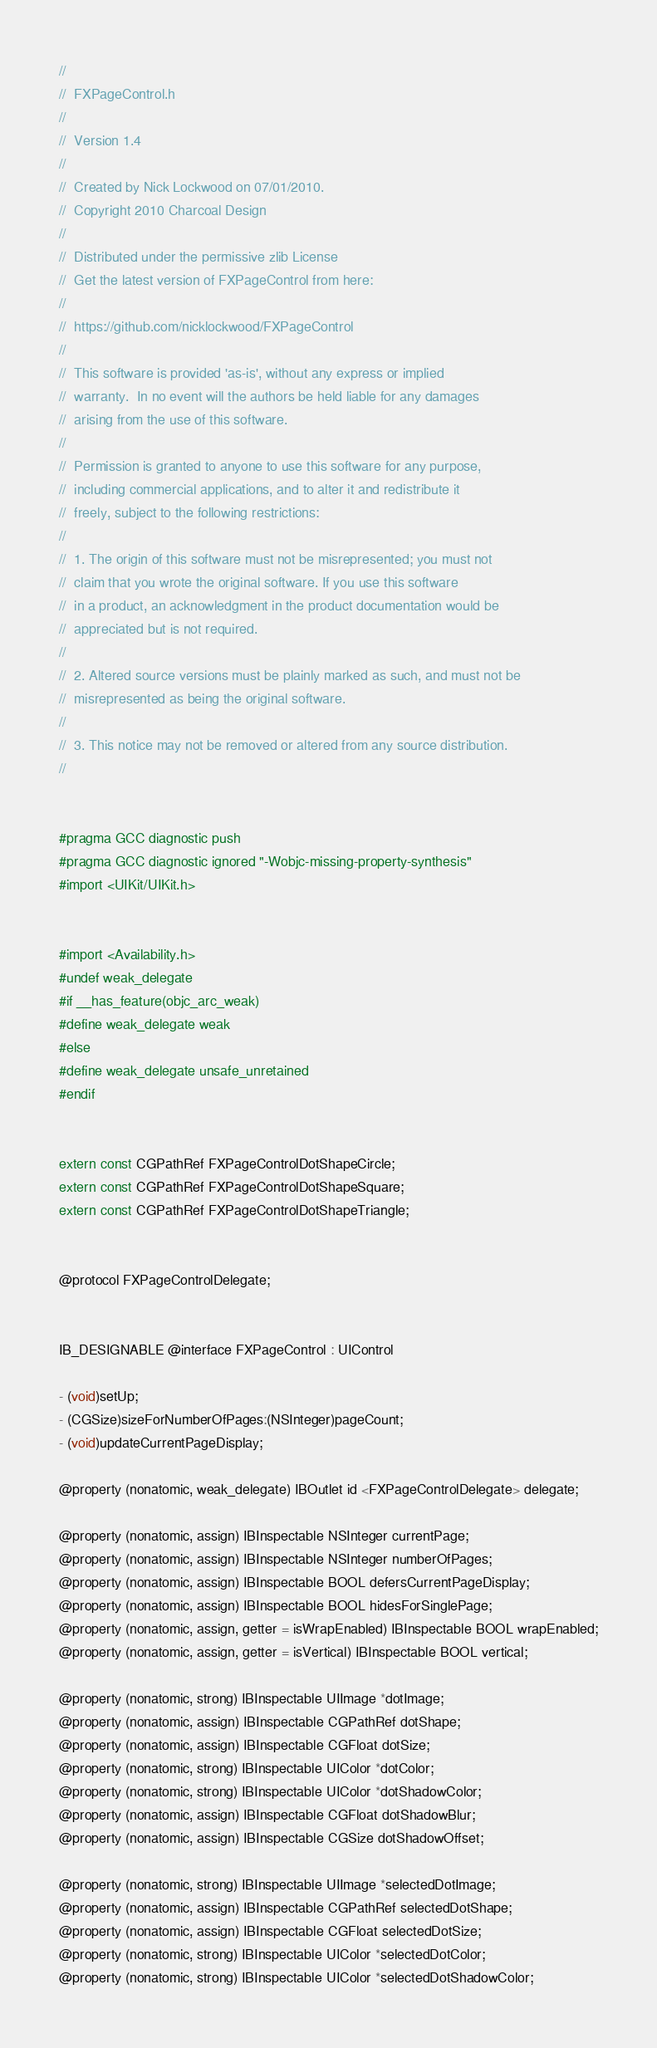<code> <loc_0><loc_0><loc_500><loc_500><_C_>//
//  FXPageControl.h
//
//  Version 1.4
//
//  Created by Nick Lockwood on 07/01/2010.
//  Copyright 2010 Charcoal Design
//
//  Distributed under the permissive zlib License
//  Get the latest version of FXPageControl from here:
//
//  https://github.com/nicklockwood/FXPageControl
//
//  This software is provided 'as-is', without any express or implied
//  warranty.  In no event will the authors be held liable for any damages
//  arising from the use of this software.
//
//  Permission is granted to anyone to use this software for any purpose,
//  including commercial applications, and to alter it and redistribute it
//  freely, subject to the following restrictions:
//
//  1. The origin of this software must not be misrepresented; you must not
//  claim that you wrote the original software. If you use this software
//  in a product, an acknowledgment in the product documentation would be
//  appreciated but is not required.
//
//  2. Altered source versions must be plainly marked as such, and must not be
//  misrepresented as being the original software.
//
//  3. This notice may not be removed or altered from any source distribution.
//


#pragma GCC diagnostic push
#pragma GCC diagnostic ignored "-Wobjc-missing-property-synthesis"
#import <UIKit/UIKit.h>


#import <Availability.h>
#undef weak_delegate
#if __has_feature(objc_arc_weak)
#define weak_delegate weak
#else
#define weak_delegate unsafe_unretained
#endif


extern const CGPathRef FXPageControlDotShapeCircle;
extern const CGPathRef FXPageControlDotShapeSquare;
extern const CGPathRef FXPageControlDotShapeTriangle;


@protocol FXPageControlDelegate;


IB_DESIGNABLE @interface FXPageControl : UIControl

- (void)setUp;
- (CGSize)sizeForNumberOfPages:(NSInteger)pageCount;
- (void)updateCurrentPageDisplay;

@property (nonatomic, weak_delegate) IBOutlet id <FXPageControlDelegate> delegate;

@property (nonatomic, assign) IBInspectable NSInteger currentPage;
@property (nonatomic, assign) IBInspectable NSInteger numberOfPages;
@property (nonatomic, assign) IBInspectable BOOL defersCurrentPageDisplay;
@property (nonatomic, assign) IBInspectable BOOL hidesForSinglePage;
@property (nonatomic, assign, getter = isWrapEnabled) IBInspectable BOOL wrapEnabled;
@property (nonatomic, assign, getter = isVertical) IBInspectable BOOL vertical;

@property (nonatomic, strong) IBInspectable UIImage *dotImage;
@property (nonatomic, assign) IBInspectable CGPathRef dotShape;
@property (nonatomic, assign) IBInspectable CGFloat dotSize;
@property (nonatomic, strong) IBInspectable UIColor *dotColor;
@property (nonatomic, strong) IBInspectable UIColor *dotShadowColor;
@property (nonatomic, assign) IBInspectable CGFloat dotShadowBlur;
@property (nonatomic, assign) IBInspectable CGSize dotShadowOffset;

@property (nonatomic, strong) IBInspectable UIImage *selectedDotImage;
@property (nonatomic, assign) IBInspectable CGPathRef selectedDotShape;
@property (nonatomic, assign) IBInspectable CGFloat selectedDotSize;
@property (nonatomic, strong) IBInspectable UIColor *selectedDotColor;
@property (nonatomic, strong) IBInspectable UIColor *selectedDotShadowColor;</code> 